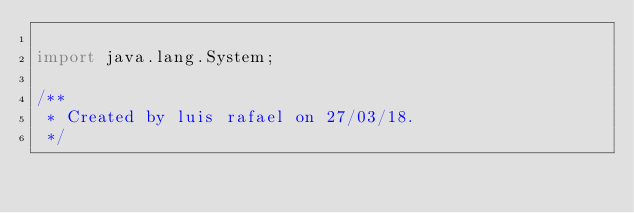<code> <loc_0><loc_0><loc_500><loc_500><_Java_>
import java.lang.System;

/**
 * Created by luis rafael on 27/03/18.
 */</code> 